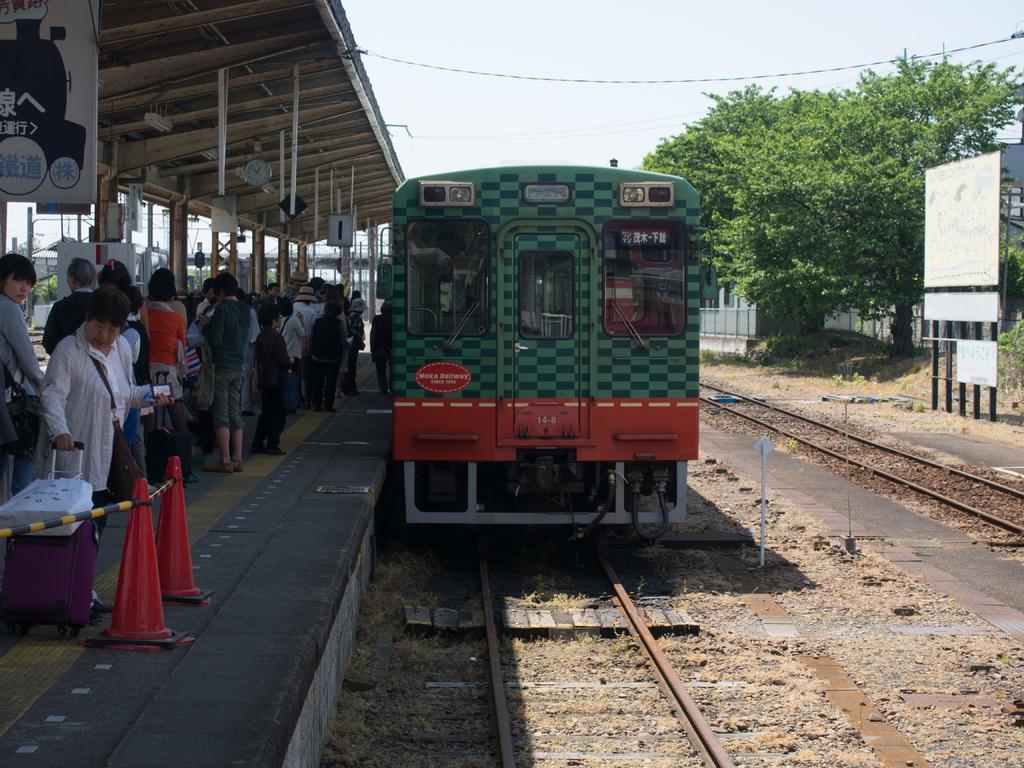How would you summarize this image in a sentence or two? This is a railway station. In the middle of the image there is a train on the railway track. On the left side many people are standing on the platform. On the right side, I can see a board, trees and building. At the top I can see the sky. 